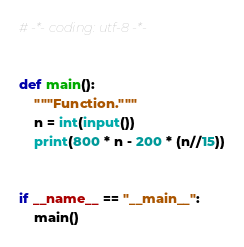<code> <loc_0><loc_0><loc_500><loc_500><_Python_># -*- coding: utf-8 -*-


def main():
    """Function."""
    n = int(input())
    print(800 * n - 200 * (n//15))


if __name__ == "__main__":
    main()
</code> 